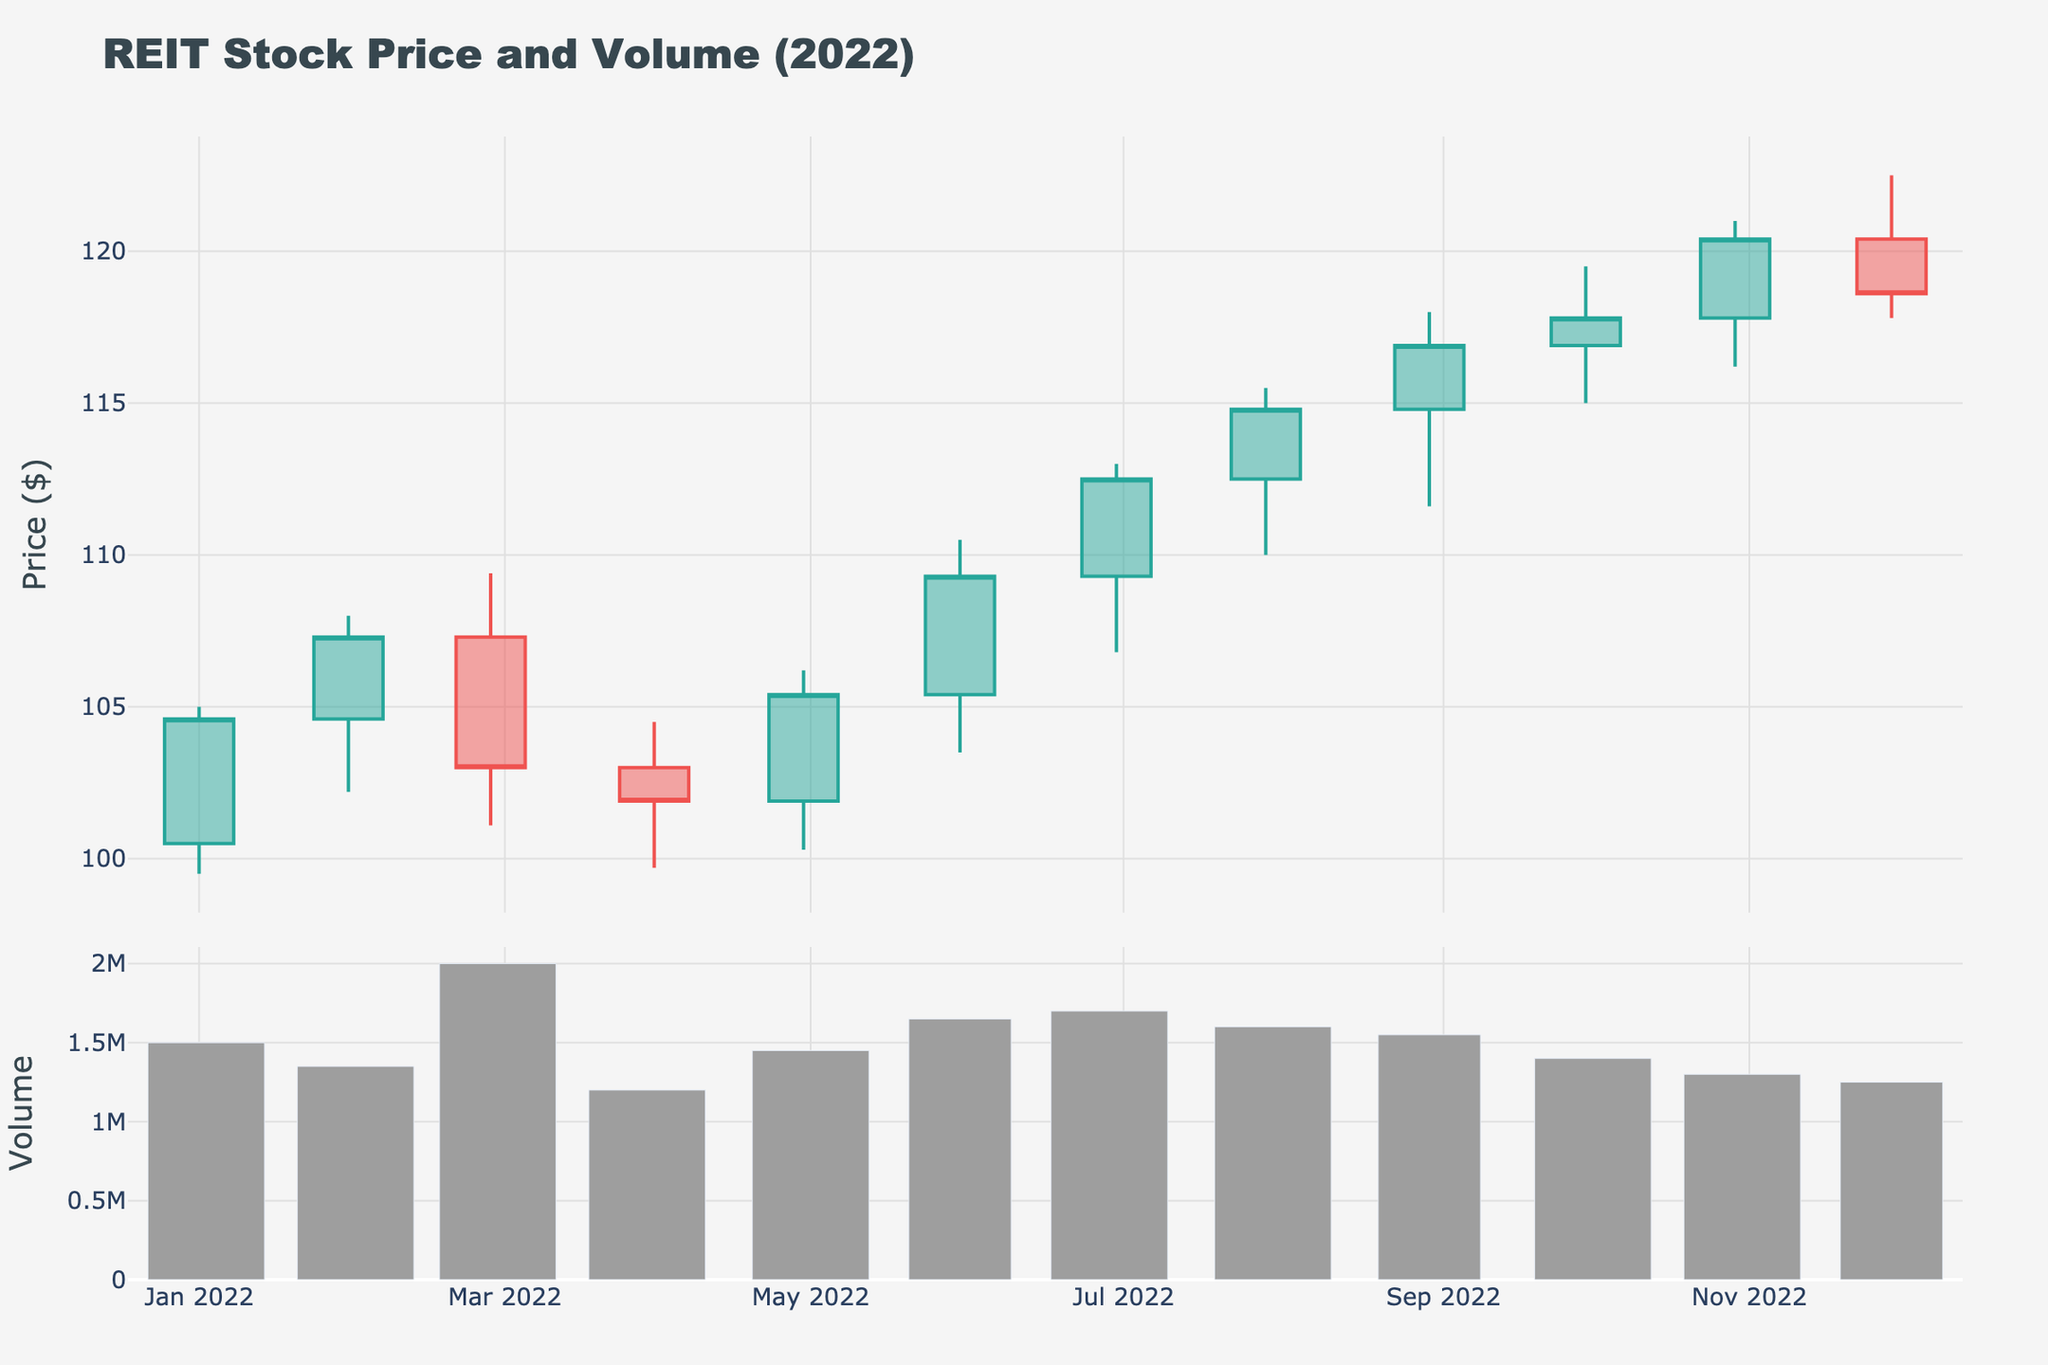What's the title of the figure? The title is located at the top of the figure, clearly stating what the plot represents.
Answer: REIT Stock Price and Volume (2022) How many data points are there in the candlestick plot? Count the number of candlesticks shown in the top subplot. Each candlestick represents one month, so there should be 12 data points for the 12 months in 2022.
Answer: 12 Which month had the highest closing price? Look at the "Close" values for each candlestick and identify the one with the highest value. The highest close is 120.4 in November.
Answer: November What is the volume for the month with the lowest closing price? Identify the month with the lowest closing price by examining the "Close" values, which is 101.9 in April. Then check the corresponding volume, which is 1,200,000.
Answer: 1,200,000 What month showed the largest spread between the high and low prices? Calculate the difference between the high and low prices for each month and identify the month with the largest spread. The largest spread is 7.9 (110.5 - 103.5) in June.
Answer: June Compare the closing prices of January and December. Which is higher? Look at the "Close" values for January and December; January has a closing price of 104.6, and December's closing price is 118.6. December's closing price is higher.
Answer: December What's the average closing price in the first quarter of 2022? Calculate the average of the closing prices for January (104.6), February (107.3), and March (103.0). The average is (104.6 + 107.3 + 103.0) / 3 = 104.97.
Answer: 104.97 Describe the trend in the volume from July to November. Observe the volume bars from July to November and describe the pattern. The volume decreases from July (1,700,000) to November (1,300,000).
Answer: Decreasing Which month experienced the lowest volume? Identify the month with the shortest volume bar in the bottom subplot, which is November with a volume of 1,300,000.
Answer: November Is there any month where the closing price is lower than the opening price? Check if the closing price is below the opening price for any candlestick; look for red candlesticks in the plot. April and December show a closing price lower than the opening price.
Answer: April and December 